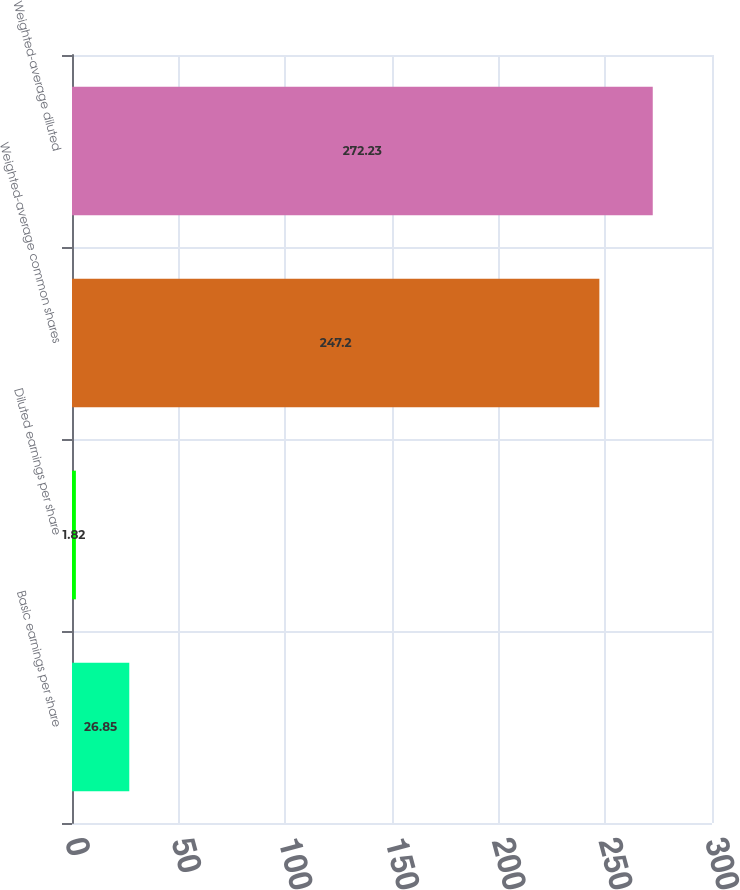Convert chart to OTSL. <chart><loc_0><loc_0><loc_500><loc_500><bar_chart><fcel>Basic earnings per share<fcel>Diluted earnings per share<fcel>Weighted-average common shares<fcel>Weighted-average diluted<nl><fcel>26.85<fcel>1.82<fcel>247.2<fcel>272.23<nl></chart> 